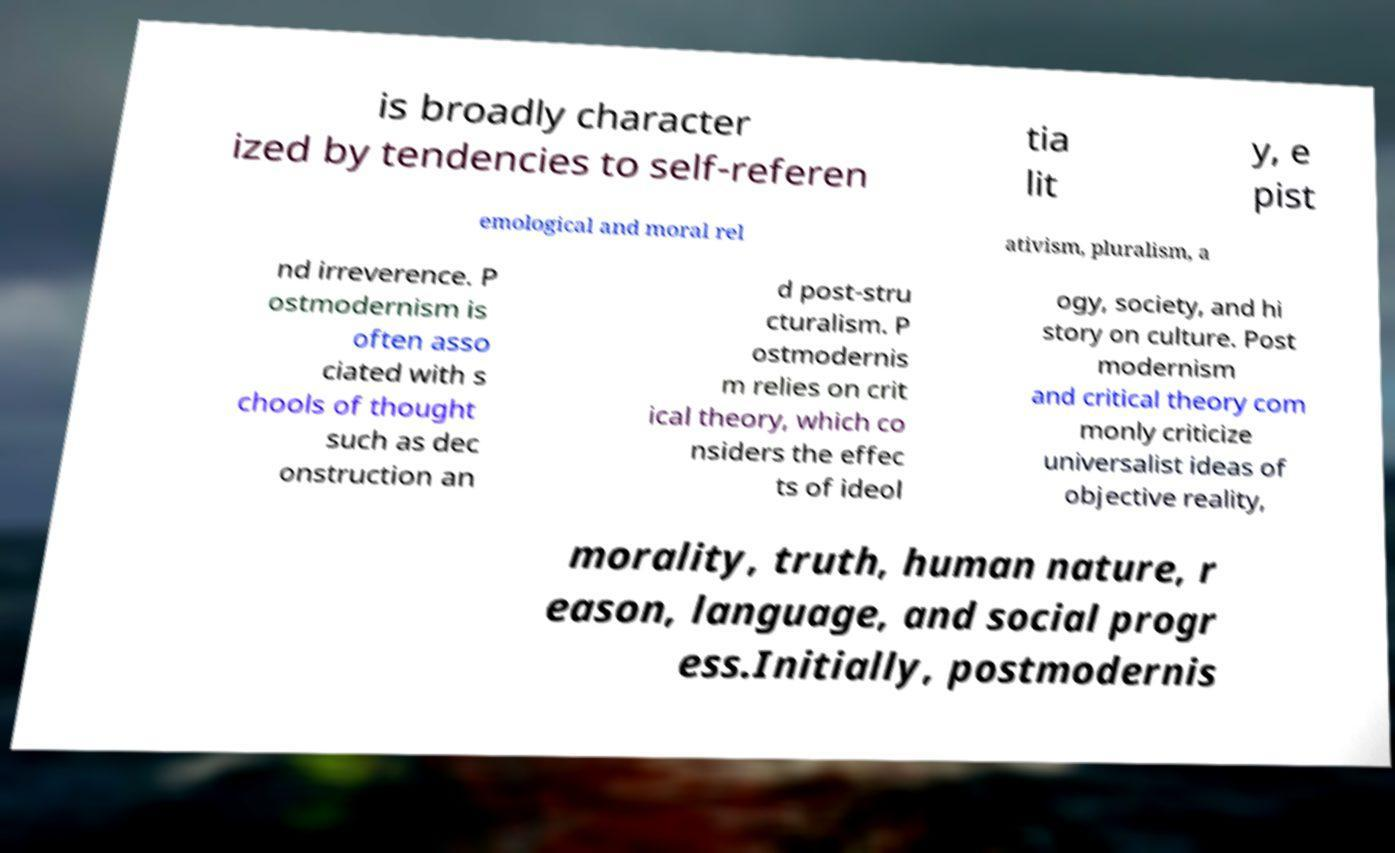Please read and relay the text visible in this image. What does it say? is broadly character ized by tendencies to self-referen tia lit y, e pist emological and moral rel ativism, pluralism, a nd irreverence. P ostmodernism is often asso ciated with s chools of thought such as dec onstruction an d post-stru cturalism. P ostmodernis m relies on crit ical theory, which co nsiders the effec ts of ideol ogy, society, and hi story on culture. Post modernism and critical theory com monly criticize universalist ideas of objective reality, morality, truth, human nature, r eason, language, and social progr ess.Initially, postmodernis 